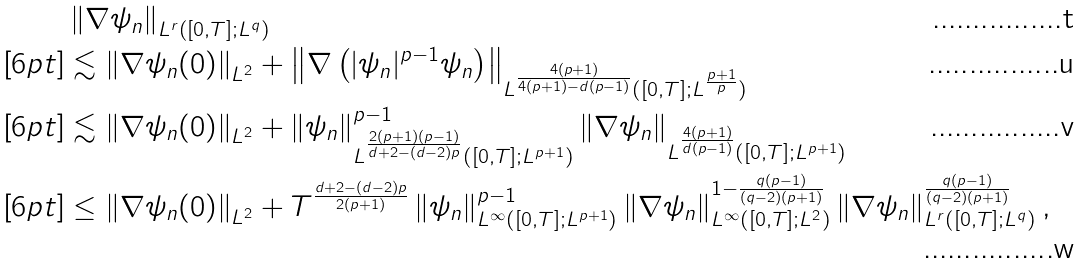<formula> <loc_0><loc_0><loc_500><loc_500>& \left \| \nabla \psi _ { n } \right \| _ { L ^ { r } \left ( [ 0 , T ] ; L ^ { q } \right ) } \\ [ 6 p t ] & \lesssim \left \| \nabla \psi _ { n } ( 0 ) \right \| _ { L ^ { 2 } } + \left \| \nabla \left ( | \psi _ { n } | ^ { p - 1 } \psi _ { n } \right ) \right \| _ { L ^ { \frac { 4 ( p + 1 ) } { 4 ( p + 1 ) - d ( p - 1 ) } } ( [ 0 , T ] ; L ^ { \frac { p + 1 } { p } } ) } \\ [ 6 p t ] & \lesssim \left \| \nabla \psi _ { n } ( 0 ) \right \| _ { L ^ { 2 } } + \left \| \psi _ { n } \right \| _ { L ^ { \frac { 2 ( p + 1 ) ( p - 1 ) } { d + 2 - ( d - 2 ) p } } ( [ 0 , T ] ; L ^ { p + 1 } ) } ^ { p - 1 } \left \| \nabla \psi _ { n } \right \| _ { L ^ { \frac { 4 ( p + 1 ) } { d ( p - 1 ) } } ( [ 0 , T ] ; L ^ { p + 1 } ) } \\ [ 6 p t ] & \leq \left \| \nabla \psi _ { n } ( 0 ) \right \| _ { L ^ { 2 } } + T ^ { \frac { d + 2 - ( d - 2 ) p } { 2 ( p + 1 ) } } \left \| \psi _ { n } \right \| _ { L ^ { \infty } ( [ 0 , T ] ; L ^ { p + 1 } ) } ^ { p - 1 } \left \| \nabla \psi _ { n } \right \| _ { L ^ { \infty } ( [ 0 , T ] ; L ^ { 2 } ) } ^ { 1 - \frac { q ( p - 1 ) } { ( q - 2 ) ( p + 1 ) } } \left \| \nabla \psi _ { n } \right \| _ { L ^ { r } ( [ 0 , T ] ; L ^ { q } ) } ^ { \frac { q ( p - 1 ) } { ( q - 2 ) ( p + 1 ) } } ,</formula> 